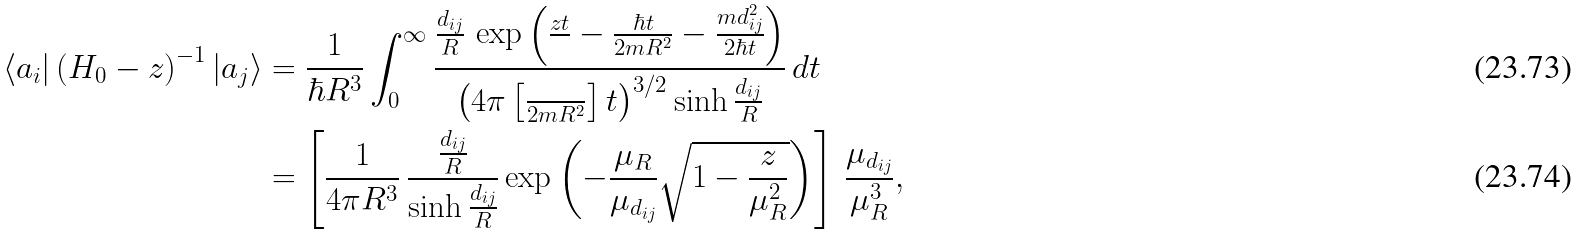<formula> <loc_0><loc_0><loc_500><loc_500>\langle a _ { i } | \left ( H _ { 0 } - z \right ) ^ { - 1 } | a _ { j } \rangle & = \frac { 1 } { \hbar { R } ^ { 3 } } \int _ { 0 } ^ { \infty } \frac { \frac { d _ { i j } } { R } \, \exp \left ( \frac { z t } { } - \frac { \hbar { t } } { 2 m R ^ { 2 } } - \frac { m d _ { i j } ^ { 2 } } { 2 \hbar { t } } \right ) } { \left ( 4 \pi \left [ \frac { } { 2 m R ^ { 2 } } \right ] t \right ) ^ { 3 / 2 } \sinh \frac { d _ { i j } } { R } } \, d t \\ & = \left [ \frac { 1 } { 4 \pi R ^ { 3 } } \, \frac { \frac { d _ { i j } } { R } } { \sinh \frac { d _ { i j } } { R } } \exp \left ( - \frac { \mu _ { R } } { \mu _ { d _ { i j } } } \sqrt { 1 - \frac { z } { \mu _ { R } ^ { 2 } } } \right ) \right ] \, \frac { \mu _ { d _ { i j } } } { \mu _ { R } ^ { 3 } } ,</formula> 